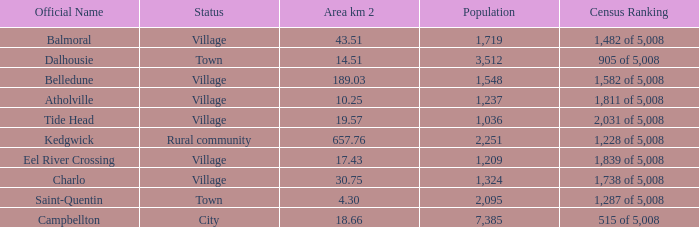When the communities name is balmoral and the area is over 4 0.0. 